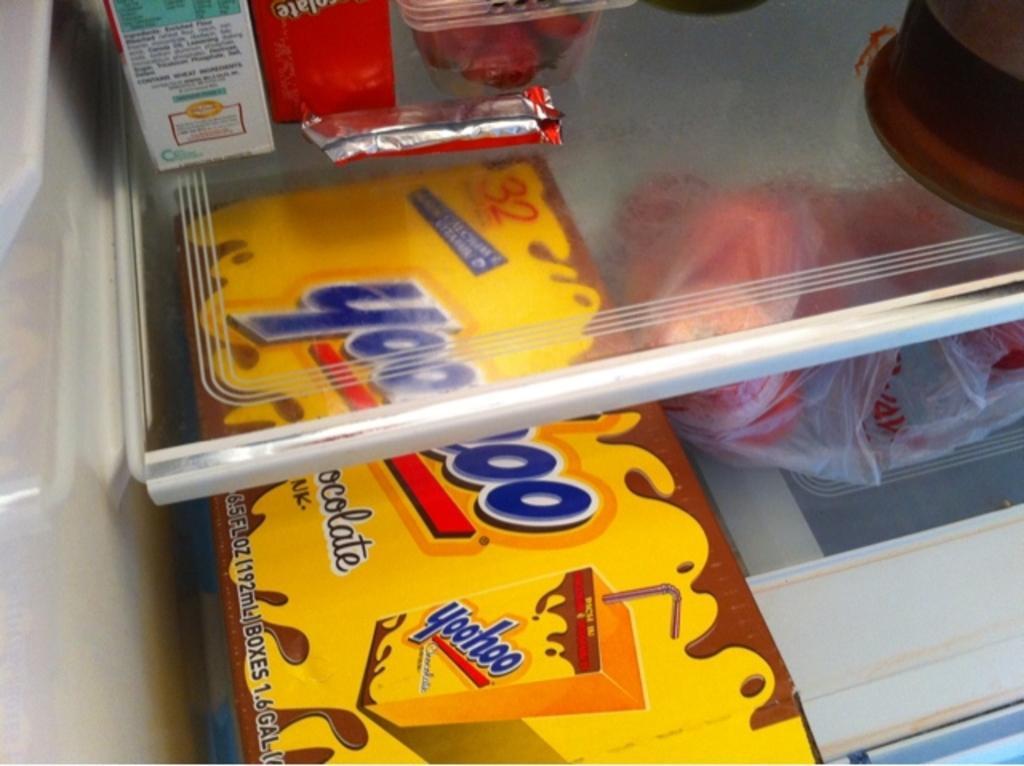In one or two sentences, can you explain what this image depicts? In this image we can see a box, cartons and a cover placed in the refrigerator. 